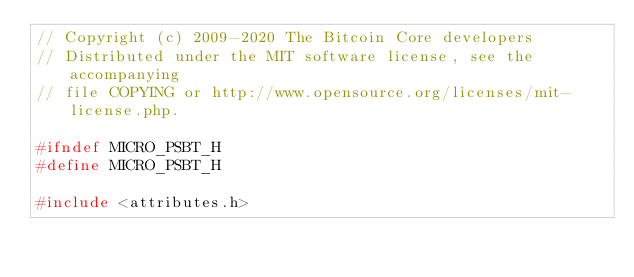Convert code to text. <code><loc_0><loc_0><loc_500><loc_500><_C_>// Copyright (c) 2009-2020 The Bitcoin Core developers
// Distributed under the MIT software license, see the accompanying
// file COPYING or http://www.opensource.org/licenses/mit-license.php.

#ifndef MICRO_PSBT_H
#define MICRO_PSBT_H

#include <attributes.h></code> 